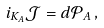<formula> <loc_0><loc_0><loc_500><loc_500>i _ { K _ { A } } \mathcal { J } = d \mathcal { P } _ { A } \, ,</formula> 